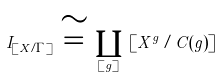Convert formula to latex. <formula><loc_0><loc_0><loc_500><loc_500>I _ { [ X / \Gamma ] } \, \cong \, \coprod _ { [ g ] } \, \left [ X ^ { g } / C ( g ) \right ]</formula> 